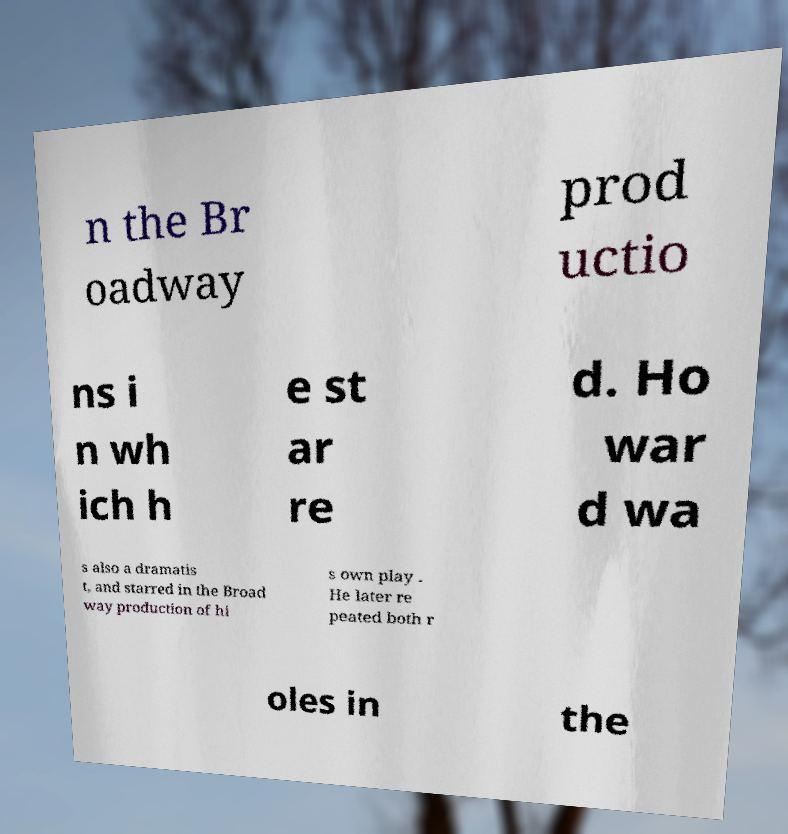Can you read and provide the text displayed in the image?This photo seems to have some interesting text. Can you extract and type it out for me? n the Br oadway prod uctio ns i n wh ich h e st ar re d. Ho war d wa s also a dramatis t, and starred in the Broad way production of hi s own play . He later re peated both r oles in the 